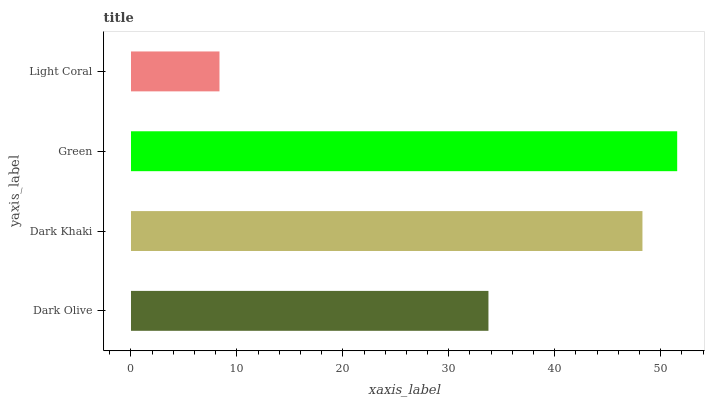Is Light Coral the minimum?
Answer yes or no. Yes. Is Green the maximum?
Answer yes or no. Yes. Is Dark Khaki the minimum?
Answer yes or no. No. Is Dark Khaki the maximum?
Answer yes or no. No. Is Dark Khaki greater than Dark Olive?
Answer yes or no. Yes. Is Dark Olive less than Dark Khaki?
Answer yes or no. Yes. Is Dark Olive greater than Dark Khaki?
Answer yes or no. No. Is Dark Khaki less than Dark Olive?
Answer yes or no. No. Is Dark Khaki the high median?
Answer yes or no. Yes. Is Dark Olive the low median?
Answer yes or no. Yes. Is Light Coral the high median?
Answer yes or no. No. Is Light Coral the low median?
Answer yes or no. No. 